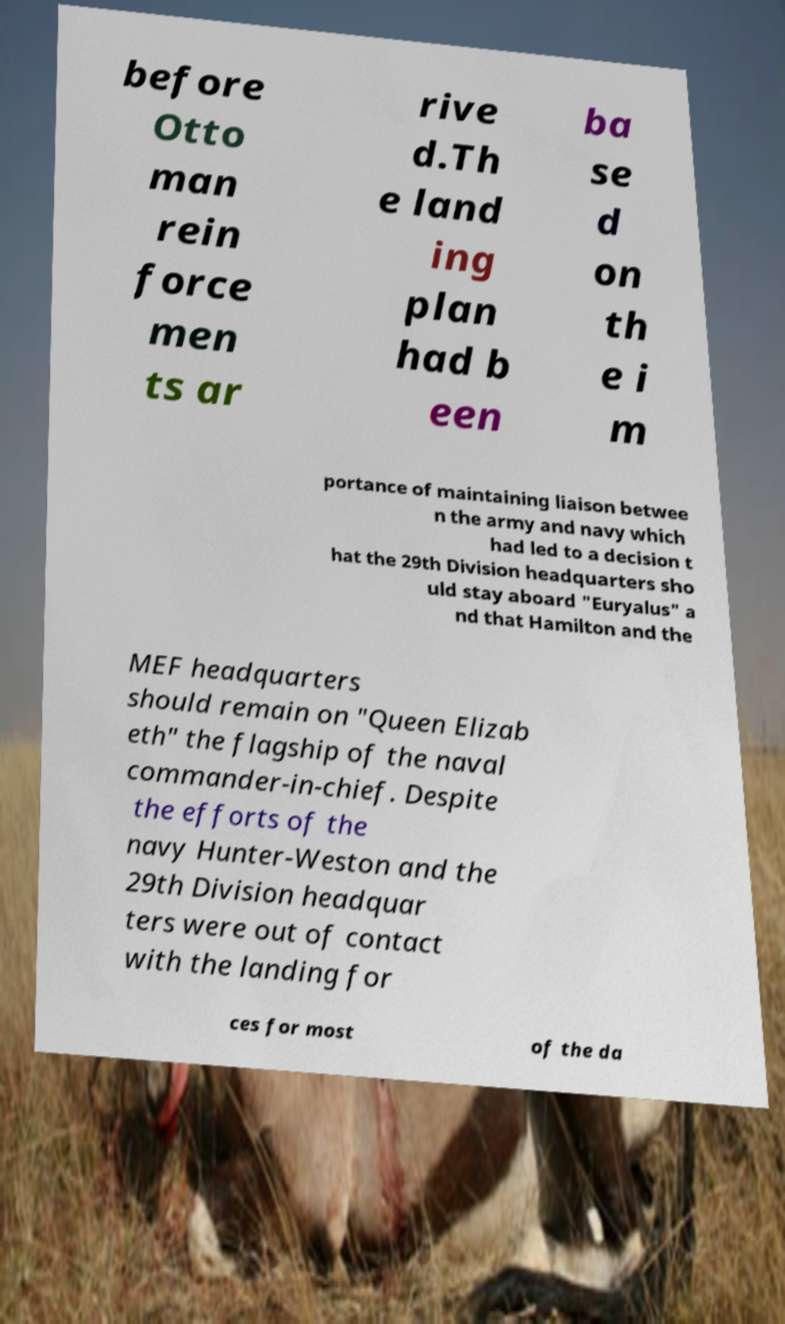Could you assist in decoding the text presented in this image and type it out clearly? before Otto man rein force men ts ar rive d.Th e land ing plan had b een ba se d on th e i m portance of maintaining liaison betwee n the army and navy which had led to a decision t hat the 29th Division headquarters sho uld stay aboard "Euryalus" a nd that Hamilton and the MEF headquarters should remain on "Queen Elizab eth" the flagship of the naval commander-in-chief. Despite the efforts of the navy Hunter-Weston and the 29th Division headquar ters were out of contact with the landing for ces for most of the da 